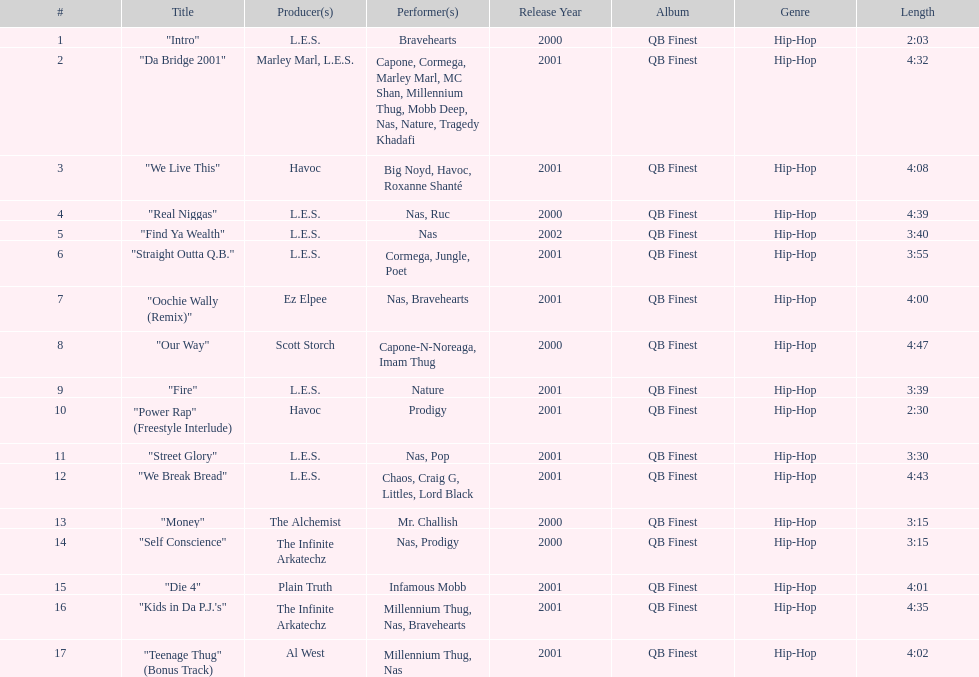Parse the table in full. {'header': ['#', 'Title', 'Producer(s)', 'Performer(s)', 'Release Year', 'Album', 'Genre', 'Length'], 'rows': [['1', '"Intro"', 'L.E.S.', 'Bravehearts', '2000', 'QB Finest', 'Hip-Hop', '2:03'], ['2', '"Da Bridge 2001"', 'Marley Marl, L.E.S.', 'Capone, Cormega, Marley Marl, MC Shan, Millennium Thug, Mobb Deep, Nas, Nature, Tragedy Khadafi', '2001', 'QB Finest', 'Hip-Hop', '4:32'], ['3', '"We Live This"', 'Havoc', 'Big Noyd, Havoc, Roxanne Shanté', '2001', 'QB Finest', 'Hip-Hop', '4:08'], ['4', '"Real Niggas"', 'L.E.S.', 'Nas, Ruc', '2000', 'QB Finest', 'Hip-Hop', '4:39'], ['5', '"Find Ya Wealth"', 'L.E.S.', 'Nas', '2002', 'QB Finest', 'Hip-Hop', '3:40'], ['6', '"Straight Outta Q.B."', 'L.E.S.', 'Cormega, Jungle, Poet', '2001', 'QB Finest', 'Hip-Hop', '3:55'], ['7', '"Oochie Wally (Remix)"', 'Ez Elpee', 'Nas, Bravehearts', '2001', 'QB Finest', 'Hip-Hop', '4:00'], ['8', '"Our Way"', 'Scott Storch', 'Capone-N-Noreaga, Imam Thug', '2000', 'QB Finest', 'Hip-Hop', '4:47'], ['9', '"Fire"', 'L.E.S.', 'Nature', '2001', 'QB Finest', 'Hip-Hop', '3:39'], ['10', '"Power Rap" (Freestyle Interlude)', 'Havoc', 'Prodigy', '2001', 'QB Finest', 'Hip-Hop', '2:30'], ['11', '"Street Glory"', 'L.E.S.', 'Nas, Pop', '2001', 'QB Finest', 'Hip-Hop', '3:30'], ['12', '"We Break Bread"', 'L.E.S.', 'Chaos, Craig G, Littles, Lord Black', '2001', 'QB Finest', 'Hip-Hop', '4:43'], ['13', '"Money"', 'The Alchemist', 'Mr. Challish', '2000', 'QB Finest', 'Hip-Hop', '3:15'], ['14', '"Self Conscience"', 'The Infinite Arkatechz', 'Nas, Prodigy', '2000', 'QB Finest', 'Hip-Hop', '3:15'], ['15', '"Die 4"', 'Plain Truth', 'Infamous Mobb', '2001', 'QB Finest', 'Hip-Hop', '4:01'], ['16', '"Kids in Da P.J.\'s"', 'The Infinite Arkatechz', 'Millennium Thug, Nas, Bravehearts', '2001', 'QB Finest', 'Hip-Hop', '4:35'], ['17', '"Teenage Thug" (Bonus Track)', 'Al West', 'Millennium Thug, Nas', '2001', 'QB Finest', 'Hip-Hop', '4:02']]} How long is the longest track listed? 4:47. 